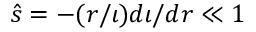Convert formula to latex. <formula><loc_0><loc_0><loc_500><loc_500>\hat { s } = - ( r / \iota ) d \iota / d r \ll 1</formula> 